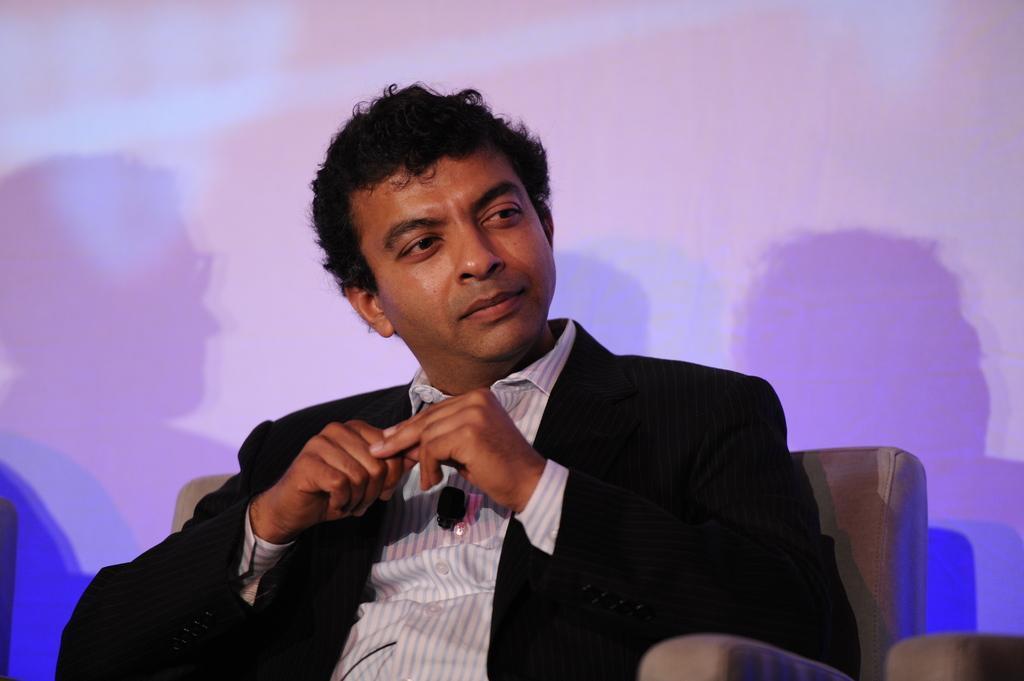In one or two sentences, can you explain what this image depicts? In the image there is a man sitting on the sofa chair. Behind him there is a wall with shadows of people. 